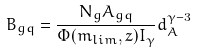<formula> <loc_0><loc_0><loc_500><loc_500>B _ { g q } = \frac { N _ { g } A _ { g q } } { \Phi ( m _ { l i m } , z ) I _ { \gamma } } d _ { A } ^ { \gamma - 3 }</formula> 